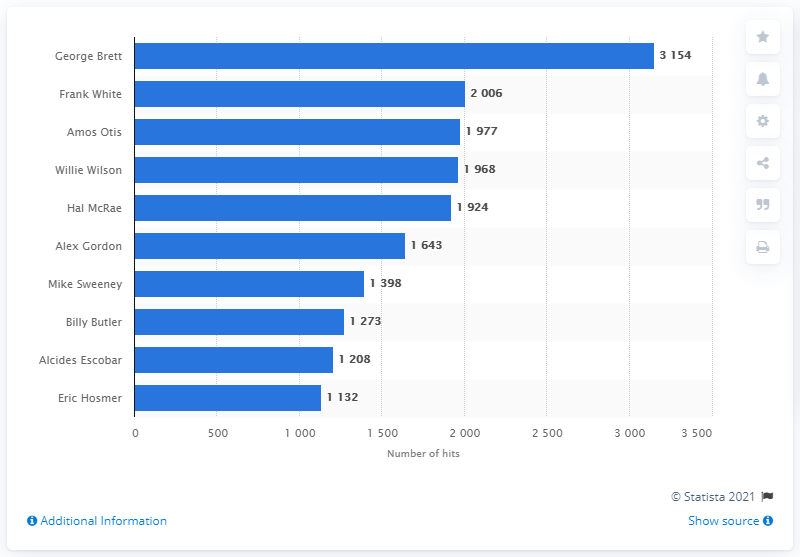Identify some key points in this picture. The Kansas City Royals franchise history has a record holder of most hits, and that player is George Brett. 